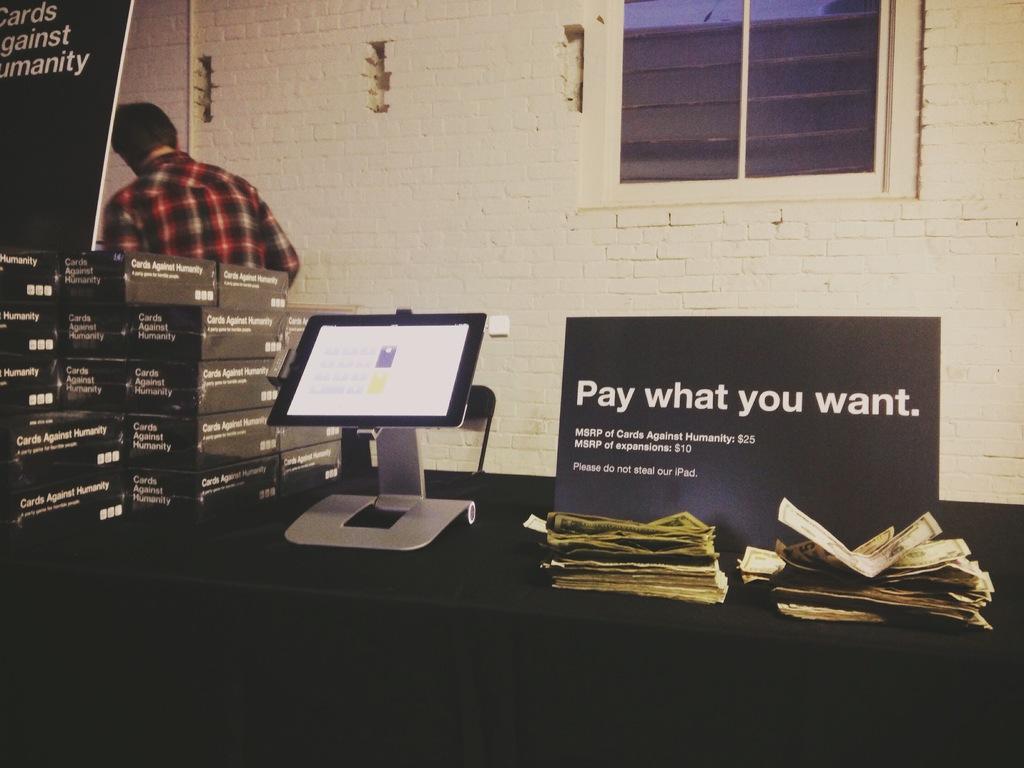Can you describe this image briefly? In this picture we can see a table in the front, there are some boxes, aboard, a tab and currency present on the table, in the background there is a wall, we can see a person on the left side, there is a window here. 